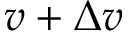Convert formula to latex. <formula><loc_0><loc_0><loc_500><loc_500>v + \Delta v</formula> 